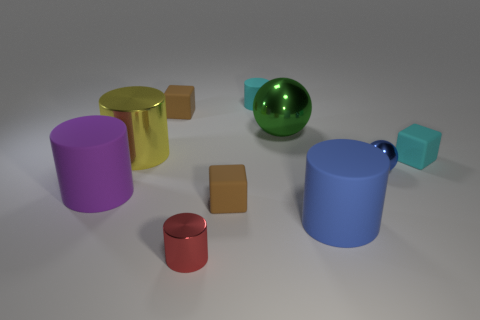Subtract 3 cylinders. How many cylinders are left? 2 Subtract all cyan matte cylinders. How many cylinders are left? 4 Subtract all yellow cylinders. How many cylinders are left? 4 Subtract all brown cylinders. Subtract all brown blocks. How many cylinders are left? 5 Subtract all cubes. How many objects are left? 7 Add 4 purple cylinders. How many purple cylinders exist? 5 Subtract 0 gray blocks. How many objects are left? 10 Subtract all large purple cylinders. Subtract all gray cubes. How many objects are left? 9 Add 8 blue shiny things. How many blue shiny things are left? 9 